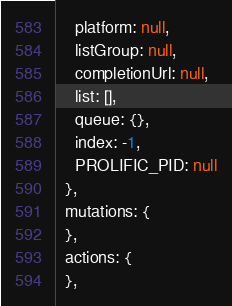Convert code to text. <code><loc_0><loc_0><loc_500><loc_500><_JavaScript_>    platform: null,
    listGroup: null,
    completionUrl: null,
    list: [],
    queue: {},
    index: -1,
    PROLIFIC_PID: null
  },
  mutations: {
  },
  actions: {
  },</code> 